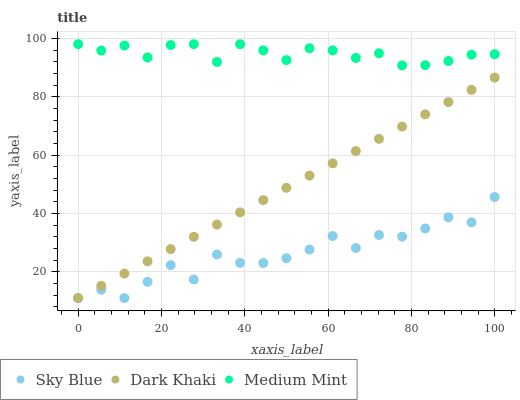Does Sky Blue have the minimum area under the curve?
Answer yes or no. Yes. Does Medium Mint have the maximum area under the curve?
Answer yes or no. Yes. Does Medium Mint have the minimum area under the curve?
Answer yes or no. No. Does Sky Blue have the maximum area under the curve?
Answer yes or no. No. Is Dark Khaki the smoothest?
Answer yes or no. Yes. Is Sky Blue the roughest?
Answer yes or no. Yes. Is Medium Mint the smoothest?
Answer yes or no. No. Is Medium Mint the roughest?
Answer yes or no. No. Does Dark Khaki have the lowest value?
Answer yes or no. Yes. Does Medium Mint have the lowest value?
Answer yes or no. No. Does Medium Mint have the highest value?
Answer yes or no. Yes. Does Sky Blue have the highest value?
Answer yes or no. No. Is Dark Khaki less than Medium Mint?
Answer yes or no. Yes. Is Medium Mint greater than Sky Blue?
Answer yes or no. Yes. Does Sky Blue intersect Dark Khaki?
Answer yes or no. Yes. Is Sky Blue less than Dark Khaki?
Answer yes or no. No. Is Sky Blue greater than Dark Khaki?
Answer yes or no. No. Does Dark Khaki intersect Medium Mint?
Answer yes or no. No. 